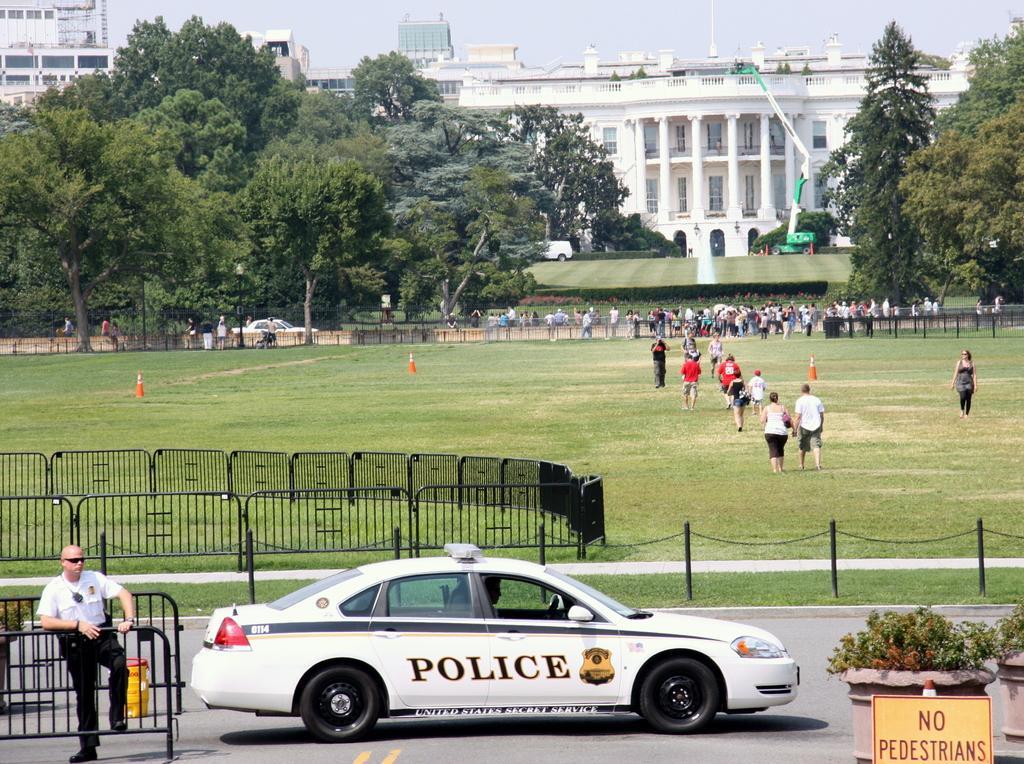Please provide a concise description of this image. In this image we can see a police car on the road, we can see a board, flower pots, a person standing, we can see barrier gates, people walking on the grass, we can see road cones, trees, crane, building and the sky in the background. 